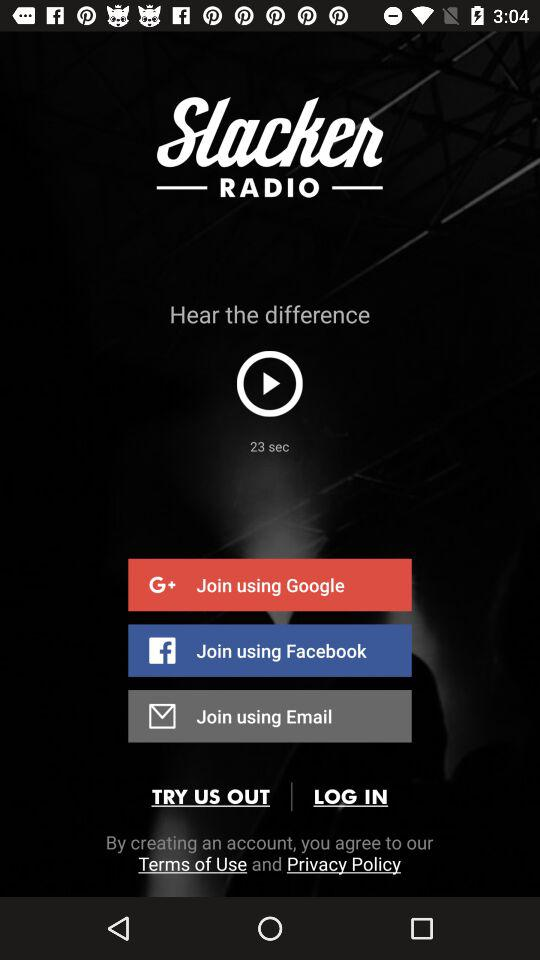What is the application name? The application name is "Slacker RADIO". 